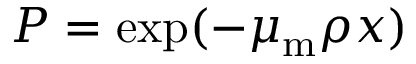<formula> <loc_0><loc_0><loc_500><loc_500>P = \exp ( { - \mu _ { m } \rho x } )</formula> 